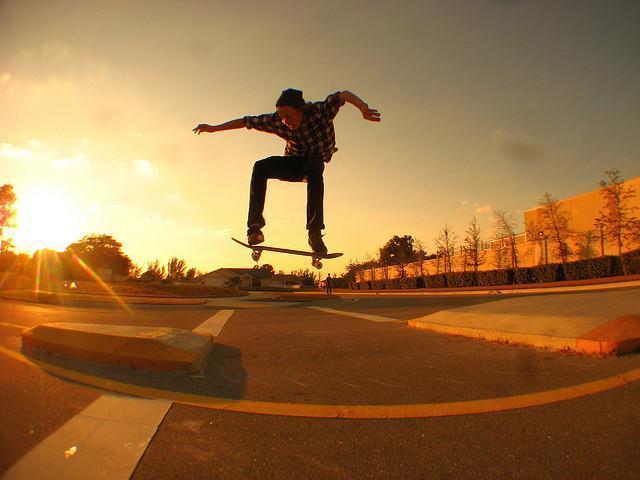How many people in the picture?
Give a very brief answer. 1. How many cars is this train engine pulling?
Give a very brief answer. 0. 